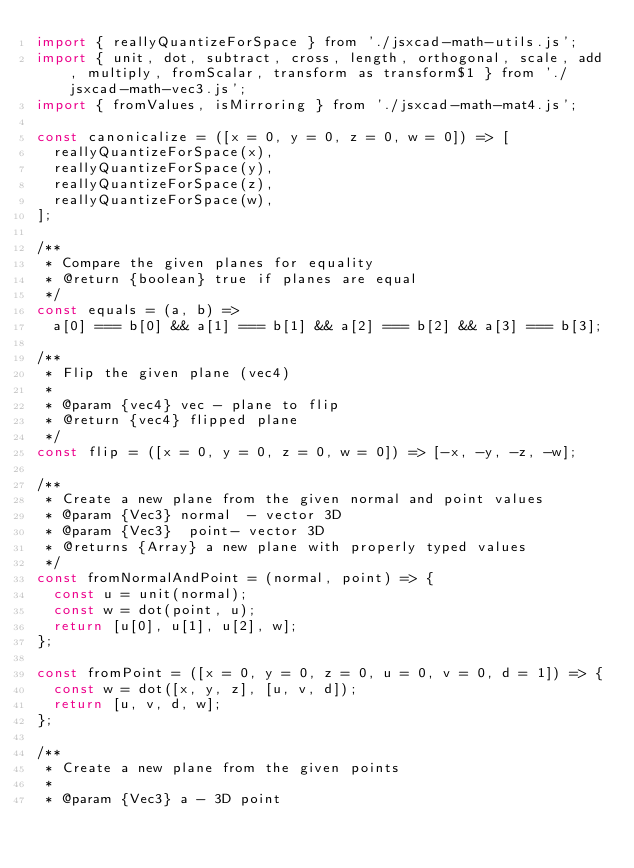Convert code to text. <code><loc_0><loc_0><loc_500><loc_500><_JavaScript_>import { reallyQuantizeForSpace } from './jsxcad-math-utils.js';
import { unit, dot, subtract, cross, length, orthogonal, scale, add, multiply, fromScalar, transform as transform$1 } from './jsxcad-math-vec3.js';
import { fromValues, isMirroring } from './jsxcad-math-mat4.js';

const canonicalize = ([x = 0, y = 0, z = 0, w = 0]) => [
  reallyQuantizeForSpace(x),
  reallyQuantizeForSpace(y),
  reallyQuantizeForSpace(z),
  reallyQuantizeForSpace(w),
];

/**
 * Compare the given planes for equality
 * @return {boolean} true if planes are equal
 */
const equals = (a, b) =>
  a[0] === b[0] && a[1] === b[1] && a[2] === b[2] && a[3] === b[3];

/**
 * Flip the given plane (vec4)
 *
 * @param {vec4} vec - plane to flip
 * @return {vec4} flipped plane
 */
const flip = ([x = 0, y = 0, z = 0, w = 0]) => [-x, -y, -z, -w];

/**
 * Create a new plane from the given normal and point values
 * @param {Vec3} normal  - vector 3D
 * @param {Vec3}  point- vector 3D
 * @returns {Array} a new plane with properly typed values
 */
const fromNormalAndPoint = (normal, point) => {
  const u = unit(normal);
  const w = dot(point, u);
  return [u[0], u[1], u[2], w];
};

const fromPoint = ([x = 0, y = 0, z = 0, u = 0, v = 0, d = 1]) => {
  const w = dot([x, y, z], [u, v, d]);
  return [u, v, d, w];
};

/**
 * Create a new plane from the given points
 *
 * @param {Vec3} a - 3D point</code> 